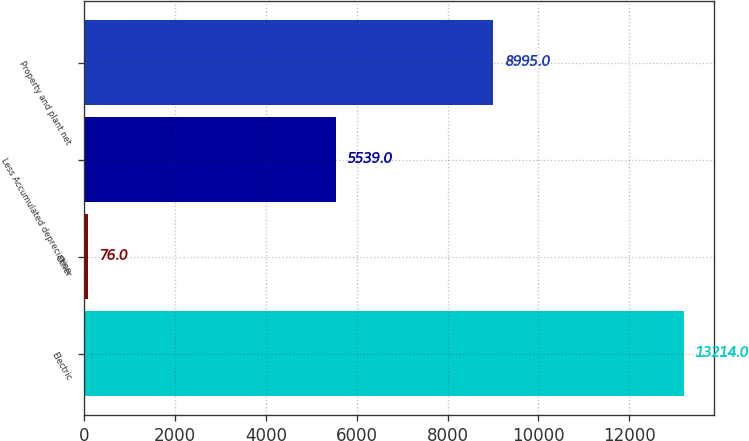Convert chart to OTSL. <chart><loc_0><loc_0><loc_500><loc_500><bar_chart><fcel>Electric<fcel>Other<fcel>Less Accumulated depreciation<fcel>Property and plant net<nl><fcel>13214<fcel>76<fcel>5539<fcel>8995<nl></chart> 